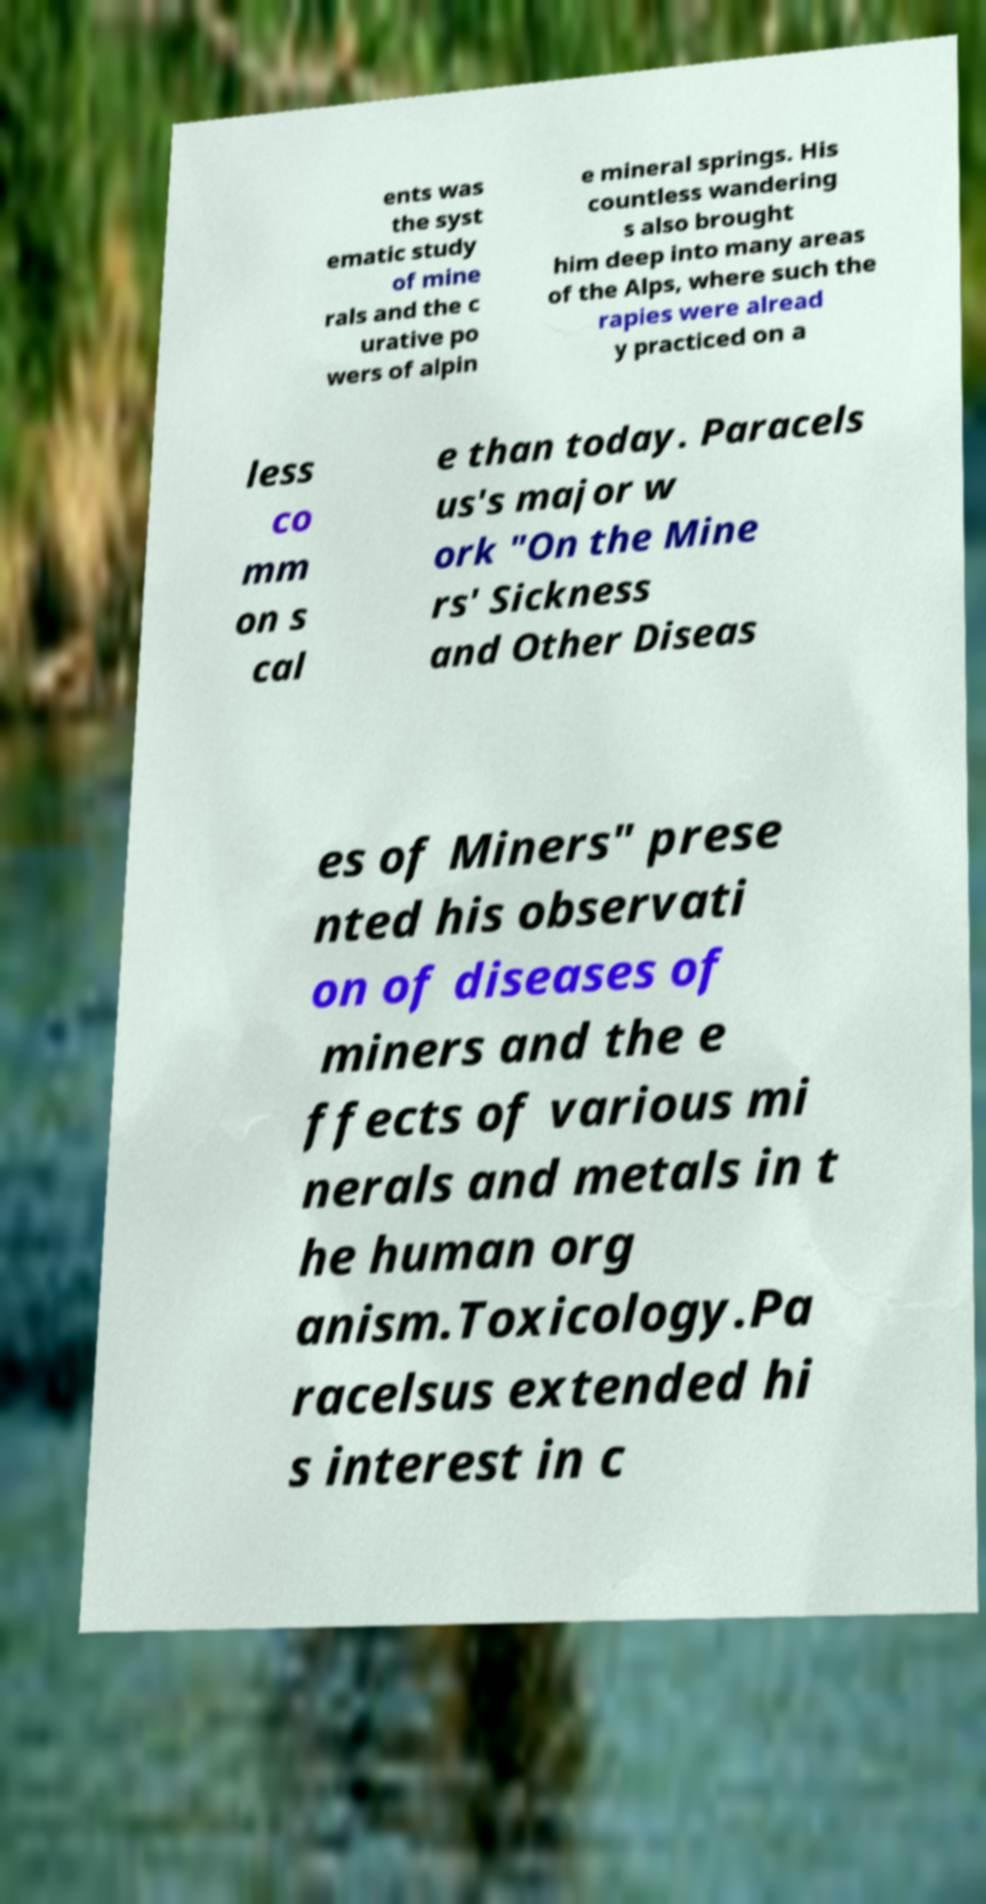Please read and relay the text visible in this image. What does it say? ents was the syst ematic study of mine rals and the c urative po wers of alpin e mineral springs. His countless wandering s also brought him deep into many areas of the Alps, where such the rapies were alread y practiced on a less co mm on s cal e than today. Paracels us's major w ork "On the Mine rs' Sickness and Other Diseas es of Miners" prese nted his observati on of diseases of miners and the e ffects of various mi nerals and metals in t he human org anism.Toxicology.Pa racelsus extended hi s interest in c 